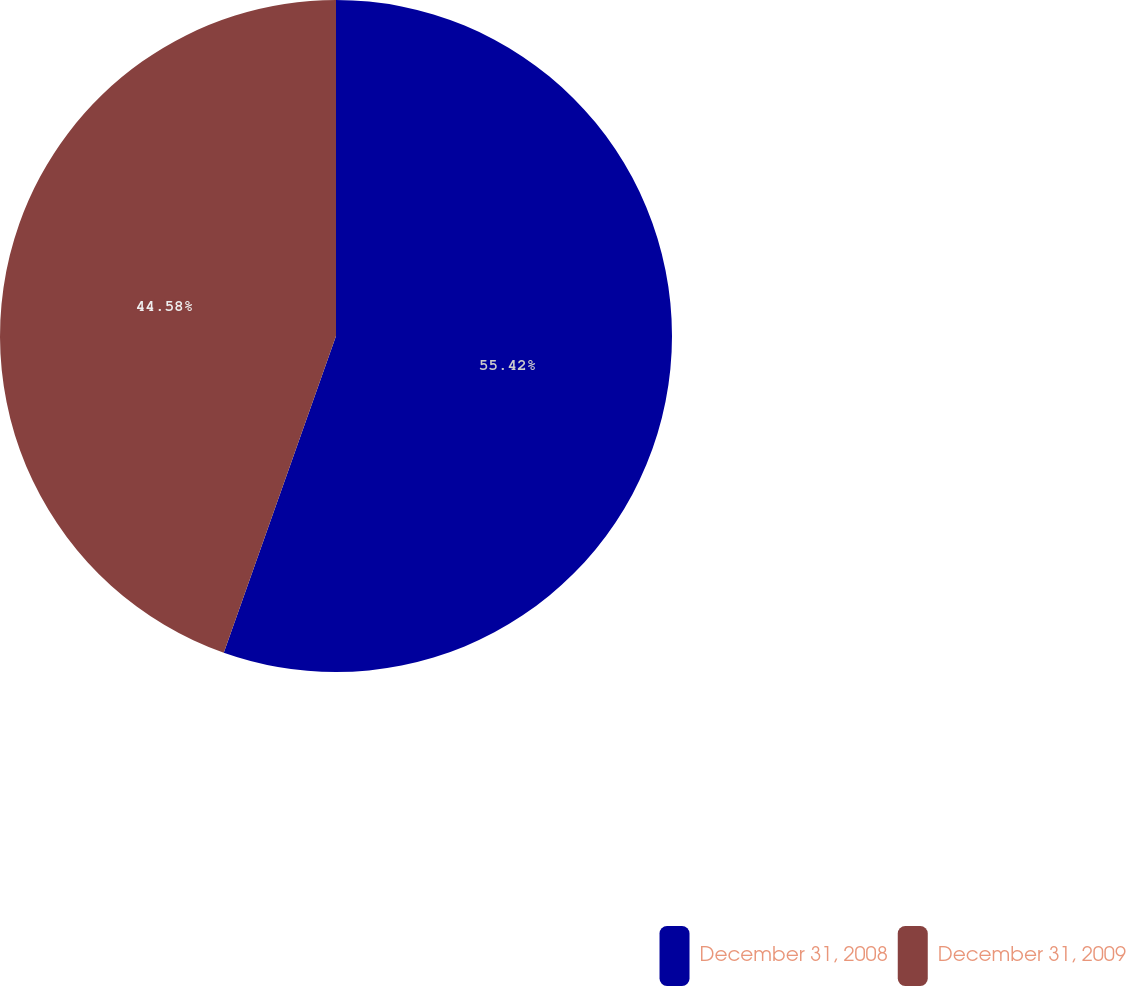<chart> <loc_0><loc_0><loc_500><loc_500><pie_chart><fcel>December 31, 2008<fcel>December 31, 2009<nl><fcel>55.42%<fcel>44.58%<nl></chart> 